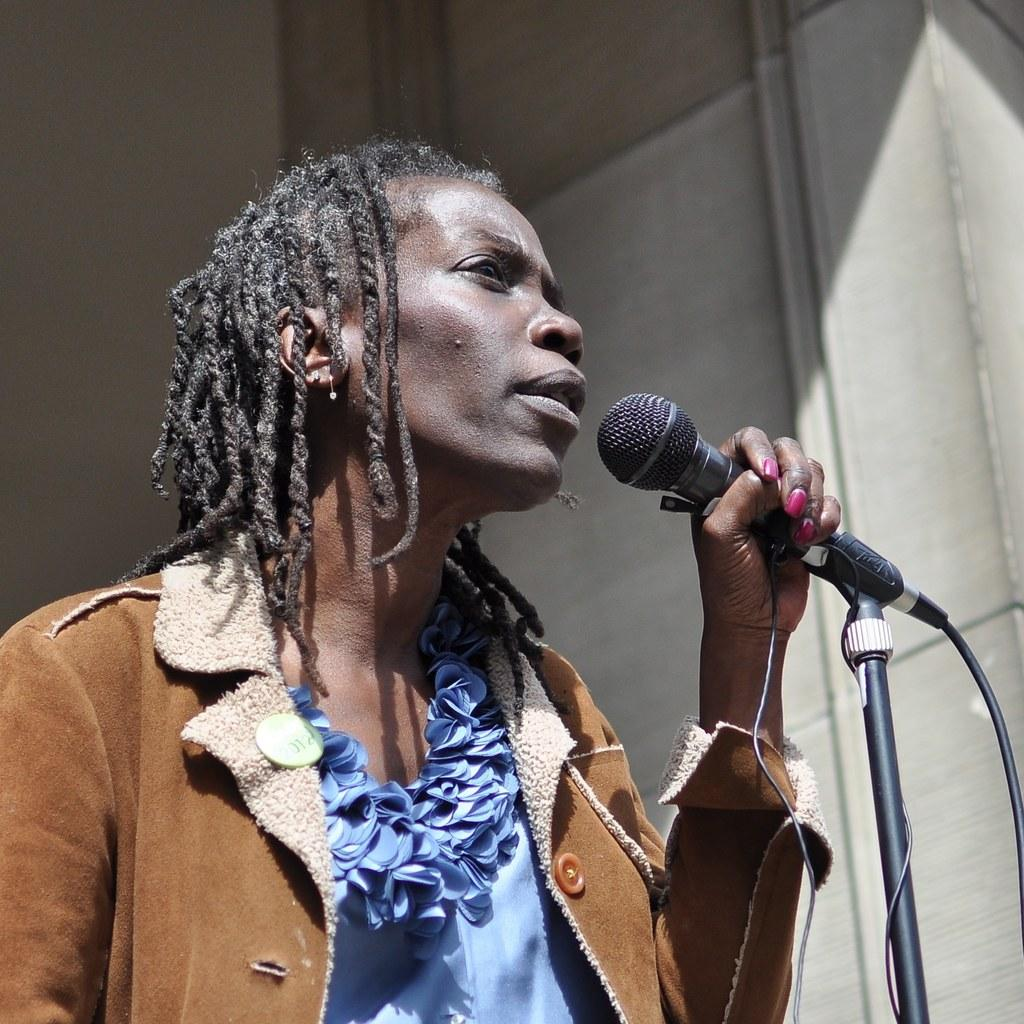Who or what is the main subject in the image? There is a person in the image. What is the person holding in their hand? The person is holding a microphone in their hand. What can be seen in the background of the image? There is a wall and pipes in the background of the image. When was the image taken? The image was taken during the day. Can you see a hen sitting on a chair in the image? There is no hen or chair present in the image. 